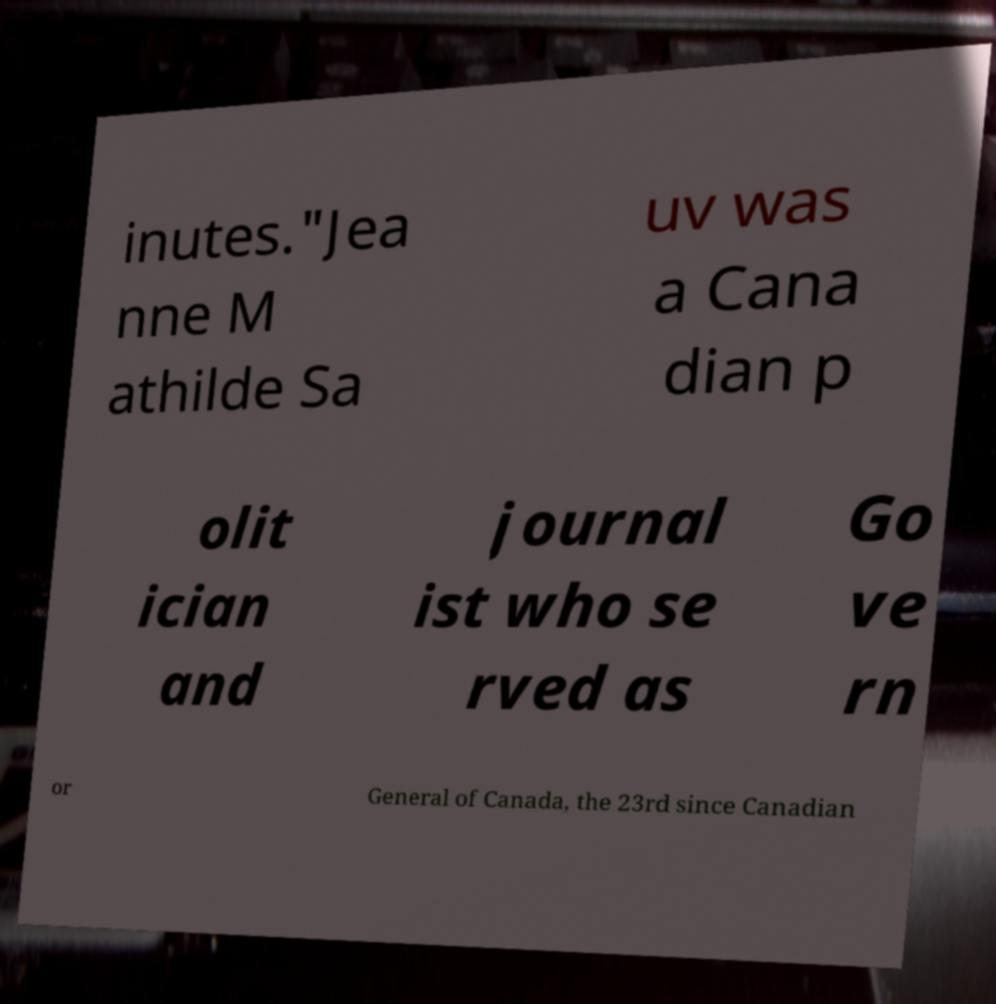Could you extract and type out the text from this image? inutes."Jea nne M athilde Sa uv was a Cana dian p olit ician and journal ist who se rved as Go ve rn or General of Canada, the 23rd since Canadian 